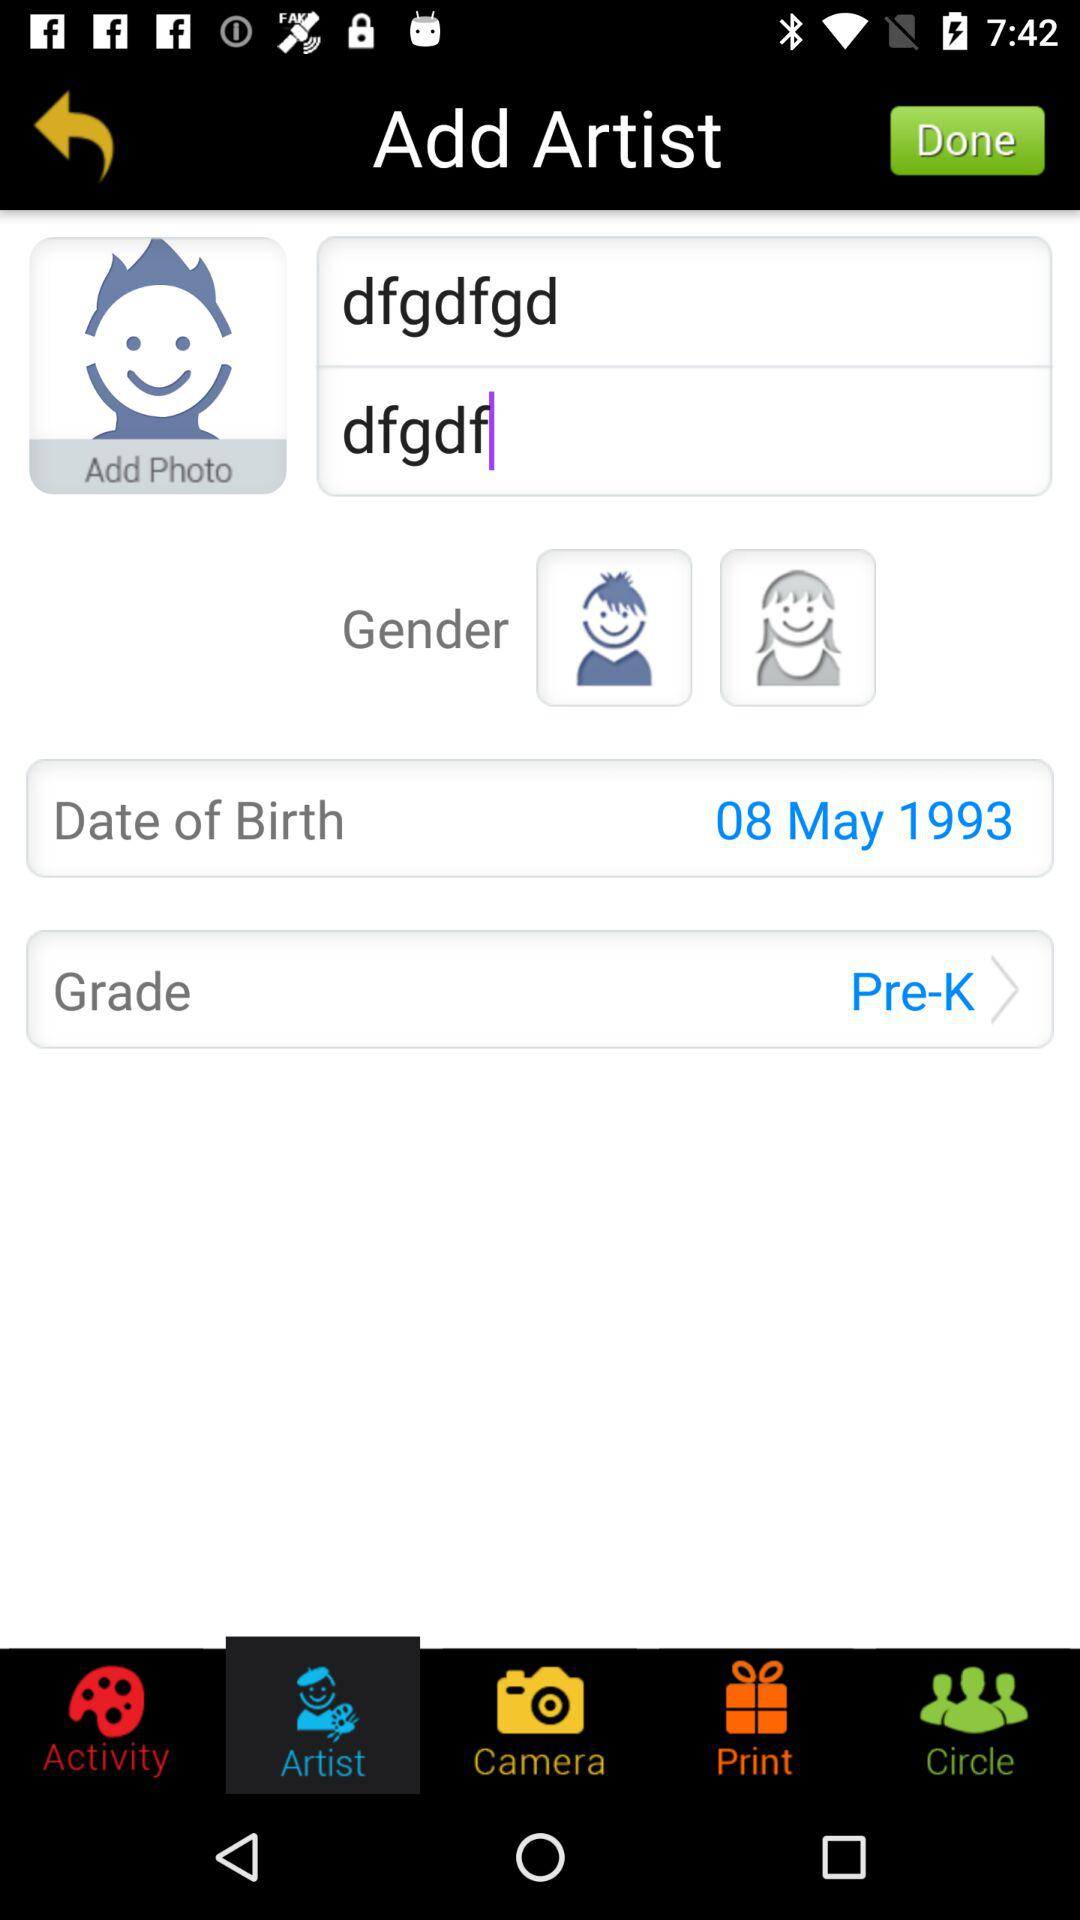What is the date of birth? The date of birth is May 8, 1993. 